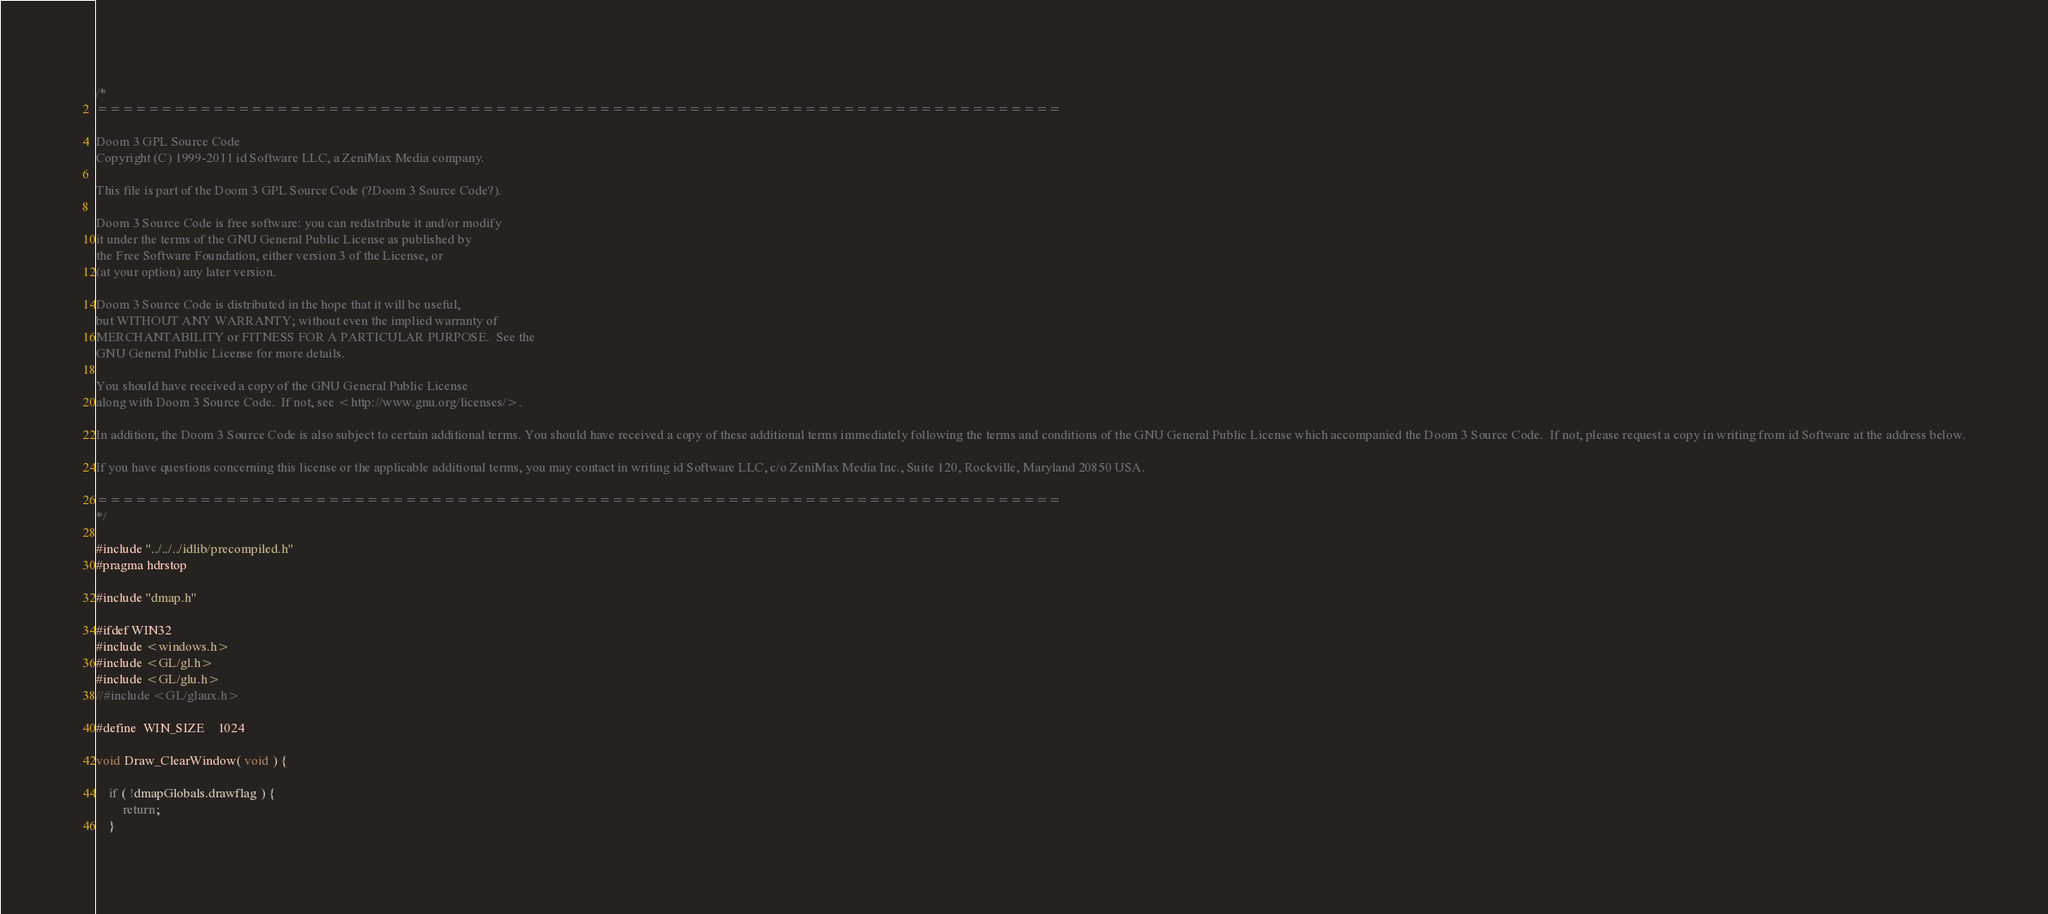<code> <loc_0><loc_0><loc_500><loc_500><_C++_>/*
===========================================================================

Doom 3 GPL Source Code
Copyright (C) 1999-2011 id Software LLC, a ZeniMax Media company. 

This file is part of the Doom 3 GPL Source Code (?Doom 3 Source Code?).  

Doom 3 Source Code is free software: you can redistribute it and/or modify
it under the terms of the GNU General Public License as published by
the Free Software Foundation, either version 3 of the License, or
(at your option) any later version.

Doom 3 Source Code is distributed in the hope that it will be useful,
but WITHOUT ANY WARRANTY; without even the implied warranty of
MERCHANTABILITY or FITNESS FOR A PARTICULAR PURPOSE.  See the
GNU General Public License for more details.

You should have received a copy of the GNU General Public License
along with Doom 3 Source Code.  If not, see <http://www.gnu.org/licenses/>.

In addition, the Doom 3 Source Code is also subject to certain additional terms. You should have received a copy of these additional terms immediately following the terms and conditions of the GNU General Public License which accompanied the Doom 3 Source Code.  If not, please request a copy in writing from id Software at the address below.

If you have questions concerning this license or the applicable additional terms, you may contact in writing id Software LLC, c/o ZeniMax Media Inc., Suite 120, Rockville, Maryland 20850 USA.

===========================================================================
*/

#include "../../../idlib/precompiled.h"
#pragma hdrstop

#include "dmap.h"

#ifdef WIN32
#include <windows.h>
#include <GL/gl.h>
#include <GL/glu.h>
//#include <GL/glaux.h>

#define	WIN_SIZE	1024

void Draw_ClearWindow( void ) {

	if ( !dmapGlobals.drawflag ) {
		return;
	}
</code> 